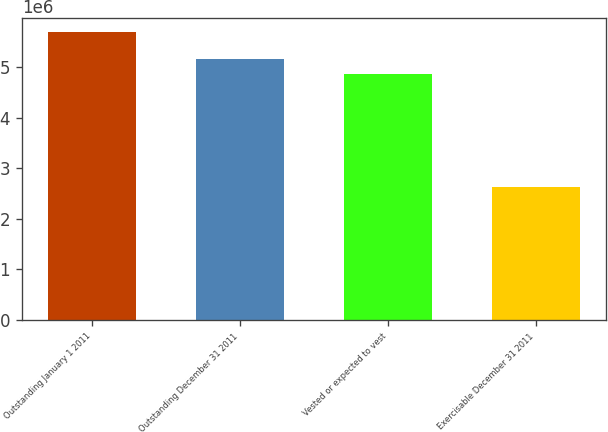Convert chart to OTSL. <chart><loc_0><loc_0><loc_500><loc_500><bar_chart><fcel>Outstanding January 1 2011<fcel>Outstanding December 31 2011<fcel>Vested or expected to vest<fcel>Exercisable December 31 2011<nl><fcel>5.69472e+06<fcel>5.17526e+06<fcel>4.86988e+06<fcel>2.64101e+06<nl></chart> 